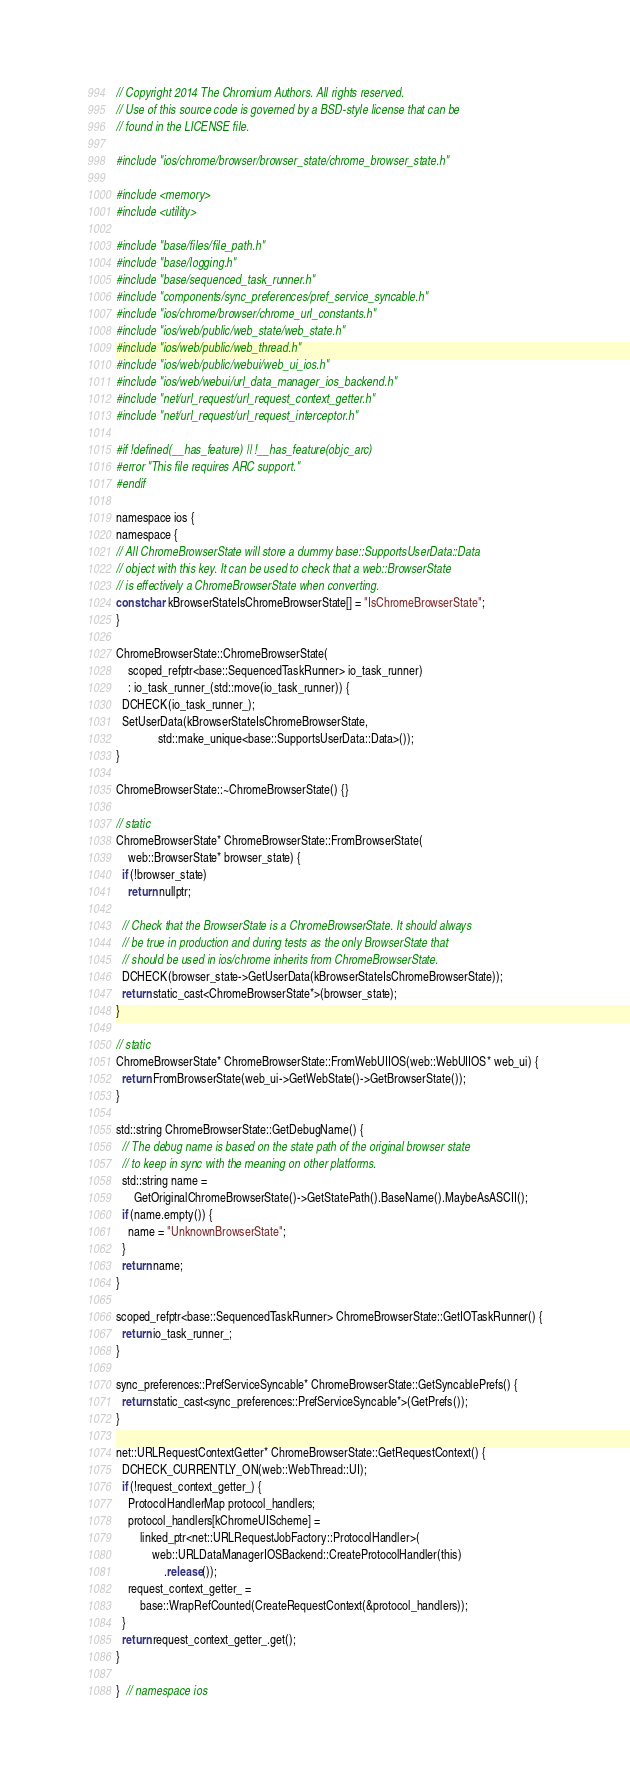<code> <loc_0><loc_0><loc_500><loc_500><_ObjectiveC_>// Copyright 2014 The Chromium Authors. All rights reserved.
// Use of this source code is governed by a BSD-style license that can be
// found in the LICENSE file.

#include "ios/chrome/browser/browser_state/chrome_browser_state.h"

#include <memory>
#include <utility>

#include "base/files/file_path.h"
#include "base/logging.h"
#include "base/sequenced_task_runner.h"
#include "components/sync_preferences/pref_service_syncable.h"
#include "ios/chrome/browser/chrome_url_constants.h"
#include "ios/web/public/web_state/web_state.h"
#include "ios/web/public/web_thread.h"
#include "ios/web/public/webui/web_ui_ios.h"
#include "ios/web/webui/url_data_manager_ios_backend.h"
#include "net/url_request/url_request_context_getter.h"
#include "net/url_request/url_request_interceptor.h"

#if !defined(__has_feature) || !__has_feature(objc_arc)
#error "This file requires ARC support."
#endif

namespace ios {
namespace {
// All ChromeBrowserState will store a dummy base::SupportsUserData::Data
// object with this key. It can be used to check that a web::BrowserState
// is effectively a ChromeBrowserState when converting.
const char kBrowserStateIsChromeBrowserState[] = "IsChromeBrowserState";
}

ChromeBrowserState::ChromeBrowserState(
    scoped_refptr<base::SequencedTaskRunner> io_task_runner)
    : io_task_runner_(std::move(io_task_runner)) {
  DCHECK(io_task_runner_);
  SetUserData(kBrowserStateIsChromeBrowserState,
              std::make_unique<base::SupportsUserData::Data>());
}

ChromeBrowserState::~ChromeBrowserState() {}

// static
ChromeBrowserState* ChromeBrowserState::FromBrowserState(
    web::BrowserState* browser_state) {
  if (!browser_state)
    return nullptr;

  // Check that the BrowserState is a ChromeBrowserState. It should always
  // be true in production and during tests as the only BrowserState that
  // should be used in ios/chrome inherits from ChromeBrowserState.
  DCHECK(browser_state->GetUserData(kBrowserStateIsChromeBrowserState));
  return static_cast<ChromeBrowserState*>(browser_state);
}

// static
ChromeBrowserState* ChromeBrowserState::FromWebUIIOS(web::WebUIIOS* web_ui) {
  return FromBrowserState(web_ui->GetWebState()->GetBrowserState());
}

std::string ChromeBrowserState::GetDebugName() {
  // The debug name is based on the state path of the original browser state
  // to keep in sync with the meaning on other platforms.
  std::string name =
      GetOriginalChromeBrowserState()->GetStatePath().BaseName().MaybeAsASCII();
  if (name.empty()) {
    name = "UnknownBrowserState";
  }
  return name;
}

scoped_refptr<base::SequencedTaskRunner> ChromeBrowserState::GetIOTaskRunner() {
  return io_task_runner_;
}

sync_preferences::PrefServiceSyncable* ChromeBrowserState::GetSyncablePrefs() {
  return static_cast<sync_preferences::PrefServiceSyncable*>(GetPrefs());
}

net::URLRequestContextGetter* ChromeBrowserState::GetRequestContext() {
  DCHECK_CURRENTLY_ON(web::WebThread::UI);
  if (!request_context_getter_) {
    ProtocolHandlerMap protocol_handlers;
    protocol_handlers[kChromeUIScheme] =
        linked_ptr<net::URLRequestJobFactory::ProtocolHandler>(
            web::URLDataManagerIOSBackend::CreateProtocolHandler(this)
                .release());
    request_context_getter_ =
        base::WrapRefCounted(CreateRequestContext(&protocol_handlers));
  }
  return request_context_getter_.get();
}

}  // namespace ios
</code> 